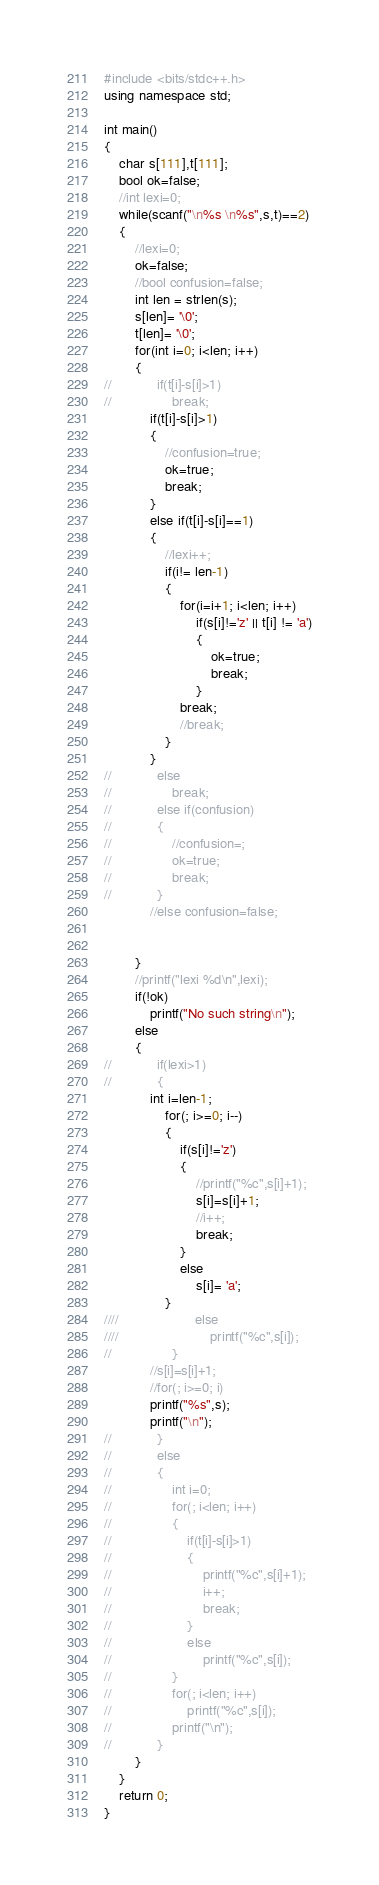<code> <loc_0><loc_0><loc_500><loc_500><_C++_>#include <bits/stdc++.h>
using namespace std;

int main()
{
    char s[111],t[111];
    bool ok=false;
    //int lexi=0;
    while(scanf("\n%s \n%s",s,t)==2)
    {
        //lexi=0;
        ok=false;
        //bool confusion=false;
        int len = strlen(s);
        s[len]= '\0';
        t[len]= '\0';
        for(int i=0; i<len; i++)
        {
//            if(t[i]-s[i]>1)
//                break;
            if(t[i]-s[i]>1)
            {
                //confusion=true;
                ok=true;
                break;
            }
            else if(t[i]-s[i]==1)
            {
                //lexi++;
                if(i!= len-1)
                {
                    for(i=i+1; i<len; i++)
                        if(s[i]!='z' || t[i] != 'a')
                        {
                            ok=true;
                            break;
                        }
                    break;
                    //break;
                }
            }
//            else
//                break;
//            else if(confusion)
//            {
//                //confusion=;
//                ok=true;
//                break;
//            }
            //else confusion=false;


        }
        //printf("lexi %d\n",lexi);
        if(!ok)
            printf("No such string\n");
        else
        {
//            if(lexi>1)
//            {
            int i=len-1;
                for(; i>=0; i--)
                {
                    if(s[i]!='z')
                    {
                        //printf("%c",s[i]+1);
                        s[i]=s[i]+1;
                        //i++;
                        break;
                    }
                    else
                        s[i]= 'a';
                }
////                    else
////                        printf("%c",s[i]);
//                }
            //s[i]=s[i]+1;
            //for(; i>=0; i)
            printf("%s",s);
            printf("\n");
//            }
//            else
//            {
//                int i=0;
//                for(; i<len; i++)
//                {
//                    if(t[i]-s[i]>1)
//                    {
//                        printf("%c",s[i]+1);
//                        i++;
//                        break;
//                    }
//                    else
//                        printf("%c",s[i]);
//                }
//                for(; i<len; i++)
//                    printf("%c",s[i]);
//                printf("\n");
//            }
        }
    }
    return 0;
}
</code> 